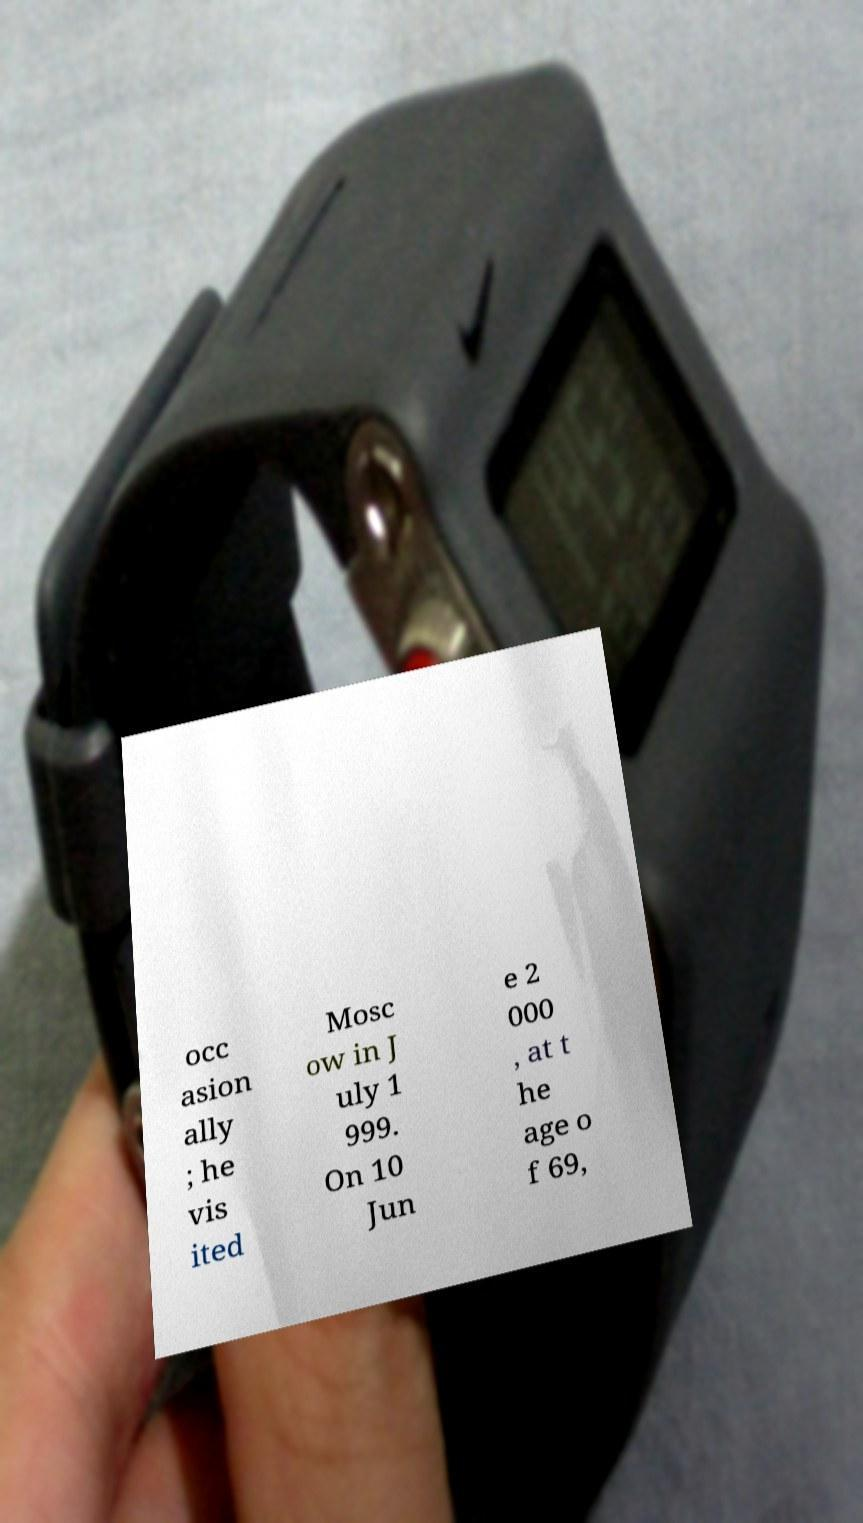Please read and relay the text visible in this image. What does it say? occ asion ally ; he vis ited Mosc ow in J uly 1 999. On 10 Jun e 2 000 , at t he age o f 69, 